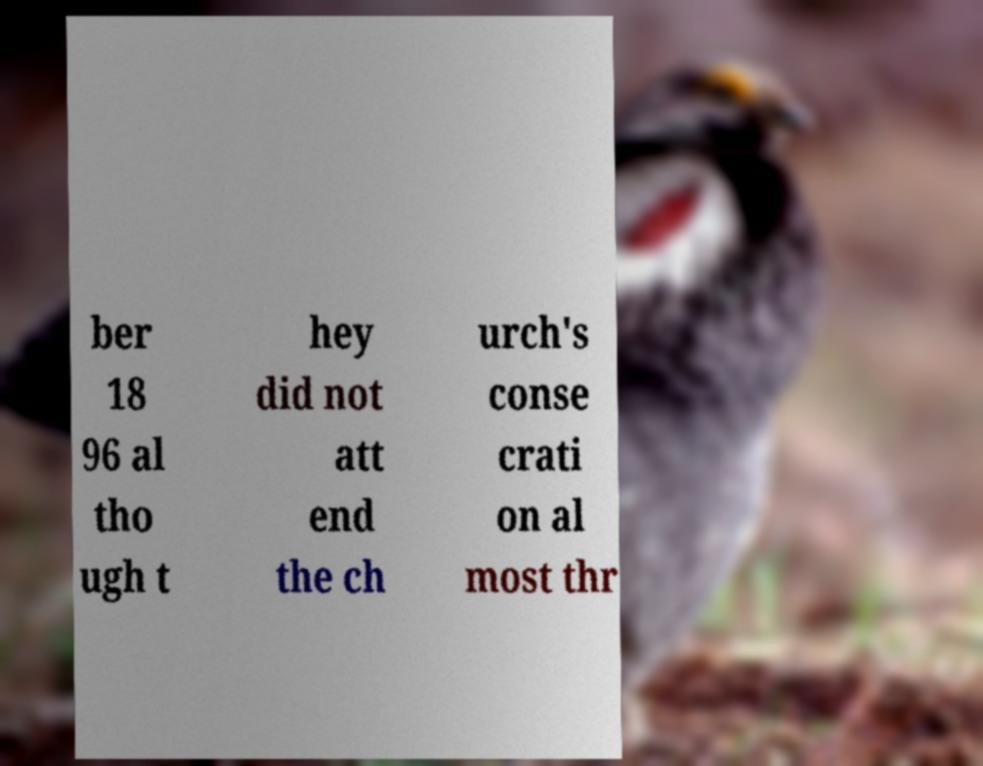Could you extract and type out the text from this image? ber 18 96 al tho ugh t hey did not att end the ch urch's conse crati on al most thr 